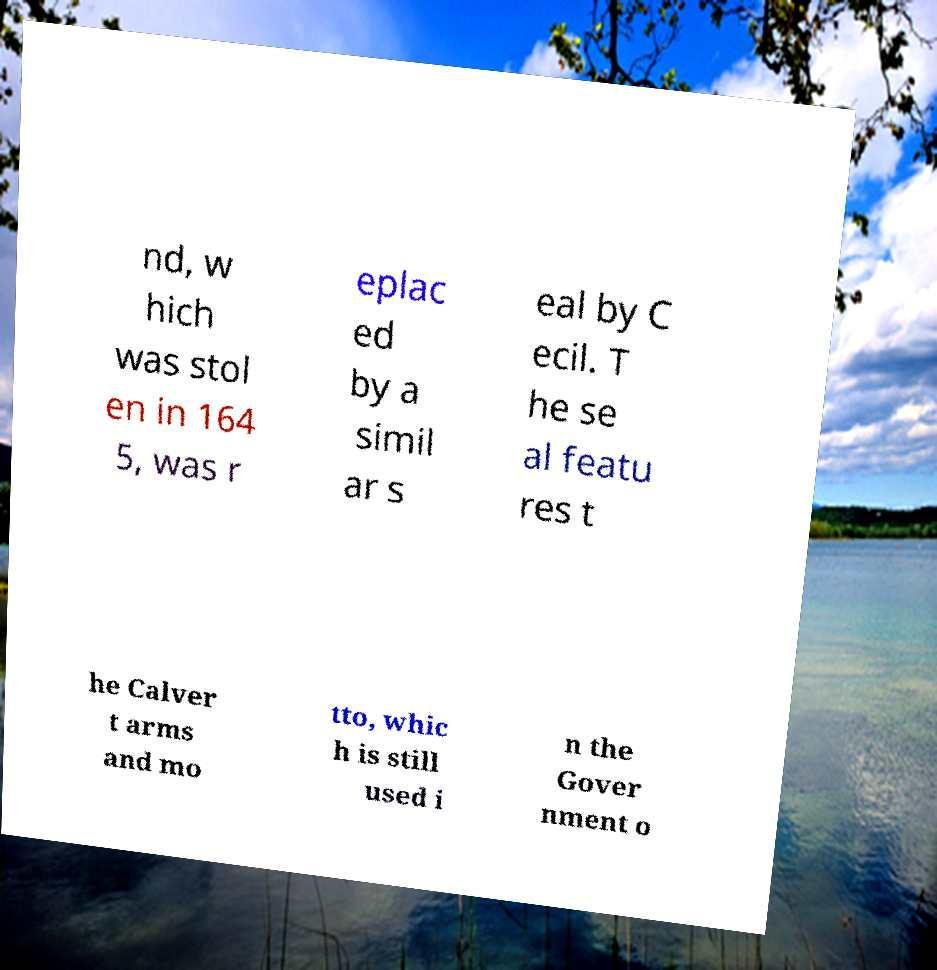What messages or text are displayed in this image? I need them in a readable, typed format. nd, w hich was stol en in 164 5, was r eplac ed by a simil ar s eal by C ecil. T he se al featu res t he Calver t arms and mo tto, whic h is still used i n the Gover nment o 